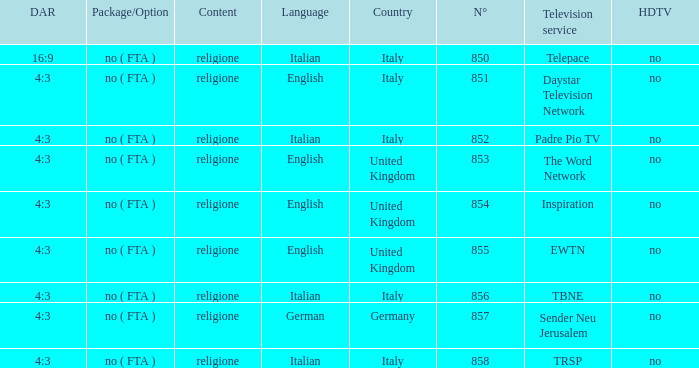Would you be able to parse every entry in this table? {'header': ['DAR', 'Package/Option', 'Content', 'Language', 'Country', 'N°', 'Television service', 'HDTV'], 'rows': [['16:9', 'no ( FTA )', 'religione', 'Italian', 'Italy', '850', 'Telepace', 'no'], ['4:3', 'no ( FTA )', 'religione', 'English', 'Italy', '851', 'Daystar Television Network', 'no'], ['4:3', 'no ( FTA )', 'religione', 'Italian', 'Italy', '852', 'Padre Pio TV', 'no'], ['4:3', 'no ( FTA )', 'religione', 'English', 'United Kingdom', '853', 'The Word Network', 'no'], ['4:3', 'no ( FTA )', 'religione', 'English', 'United Kingdom', '854', 'Inspiration', 'no'], ['4:3', 'no ( FTA )', 'religione', 'English', 'United Kingdom', '855', 'EWTN', 'no'], ['4:3', 'no ( FTA )', 'religione', 'Italian', 'Italy', '856', 'TBNE', 'no'], ['4:3', 'no ( FTA )', 'religione', 'German', 'Germany', '857', 'Sender Neu Jerusalem', 'no'], ['4:3', 'no ( FTA )', 'religione', 'Italian', 'Italy', '858', 'TRSP', 'no']]} How many television service are in italian and n°is greater than 856.0? TRSP. 